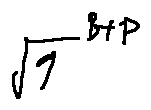<formula> <loc_0><loc_0><loc_500><loc_500>\sqrt { 9 } ^ { B + P }</formula> 